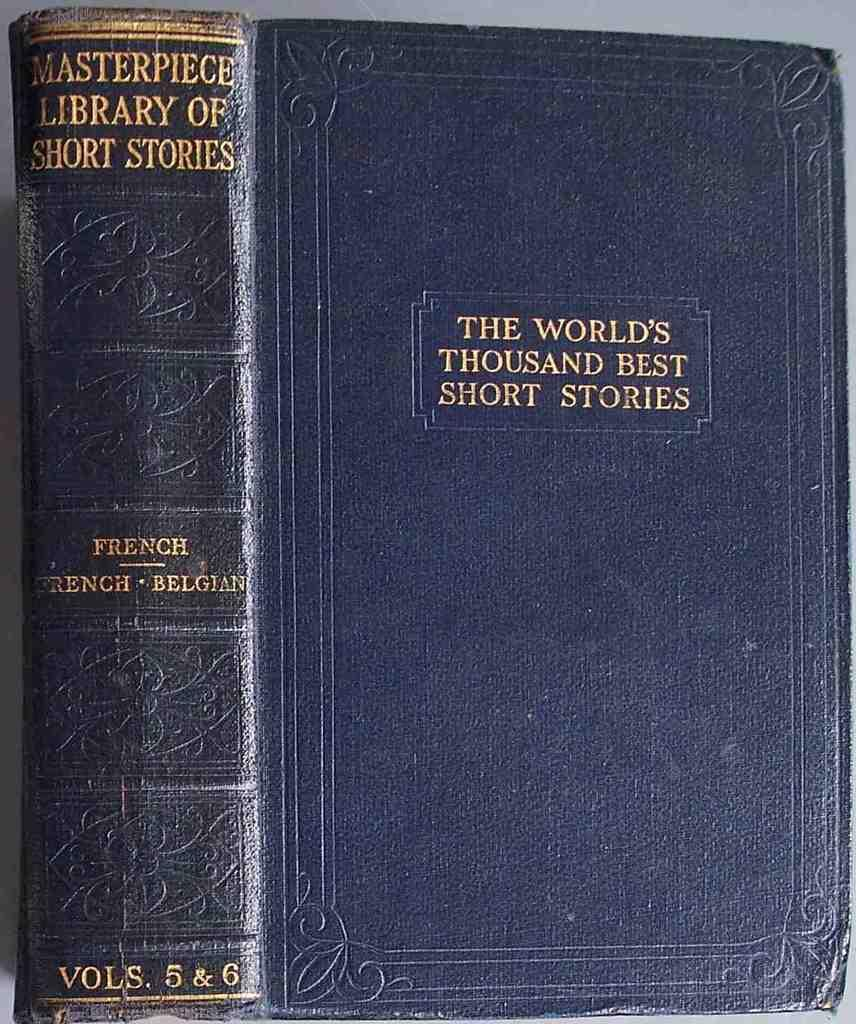Provide a one-sentence caption for the provided image. The black book is labeled The World's Thousand Best Short Stories. 